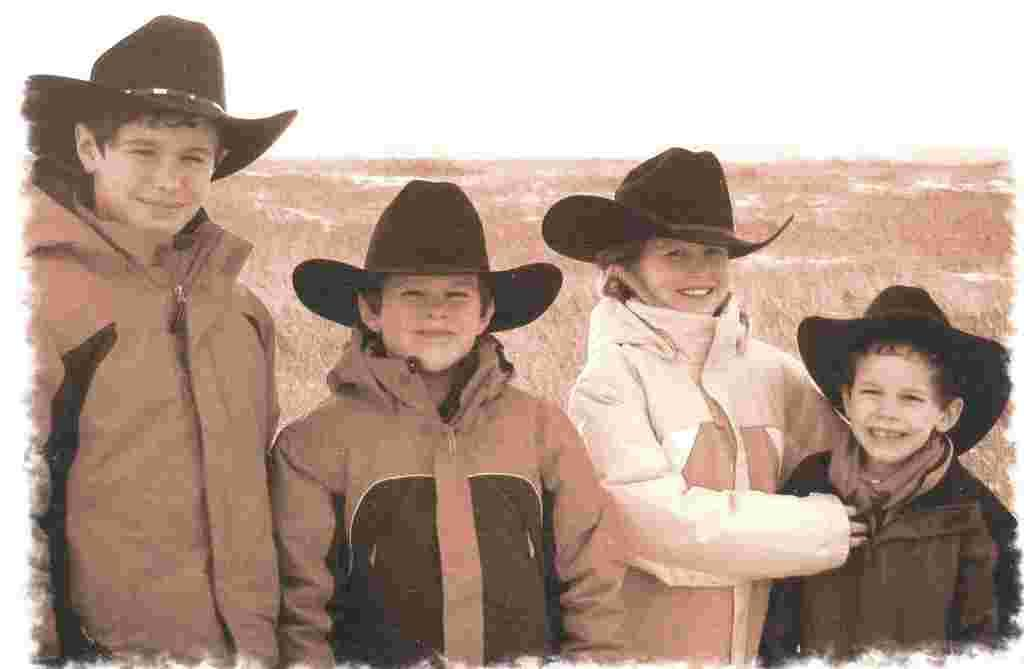What can be seen in the image? There are kids in the image. Where are the kids standing? The kids are standing on grassland. What are the kids wearing? The kids are wearing jackets and hats. What is visible at the top of the image? The sky is visible at the top of the image. What type of waves can be seen in the image? There are no waves present in the image; it features kids standing on grassland. What kind of idea is the coach discussing with the kids in the image? There is no coach or discussion present in the image; it only shows kids standing on grassland. 